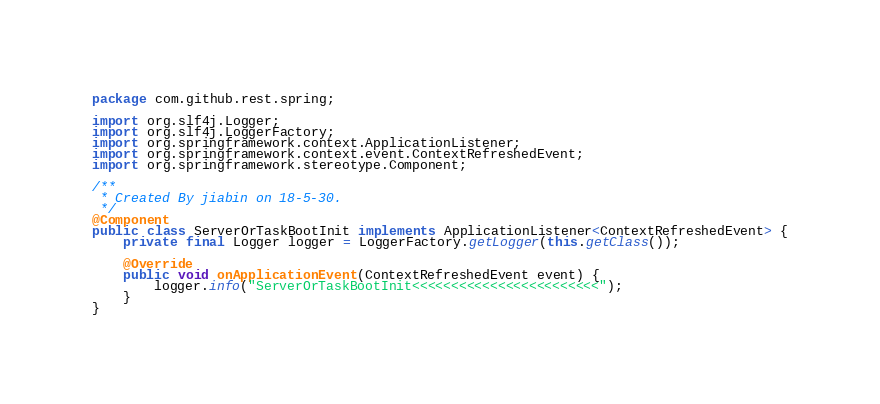<code> <loc_0><loc_0><loc_500><loc_500><_Java_>package com.github.rest.spring;

import org.slf4j.Logger;
import org.slf4j.LoggerFactory;
import org.springframework.context.ApplicationListener;
import org.springframework.context.event.ContextRefreshedEvent;
import org.springframework.stereotype.Component;

/**
 * Created By jiabin on 18-5-30.
 */
@Component
public class ServerOrTaskBootInit implements ApplicationListener<ContextRefreshedEvent> {
    private final Logger logger = LoggerFactory.getLogger(this.getClass());

    @Override
    public void onApplicationEvent(ContextRefreshedEvent event) {
        logger.info("ServerOrTaskBootInit<<<<<<<<<<<<<<<<<<<<<<<<");
    }
}
</code> 